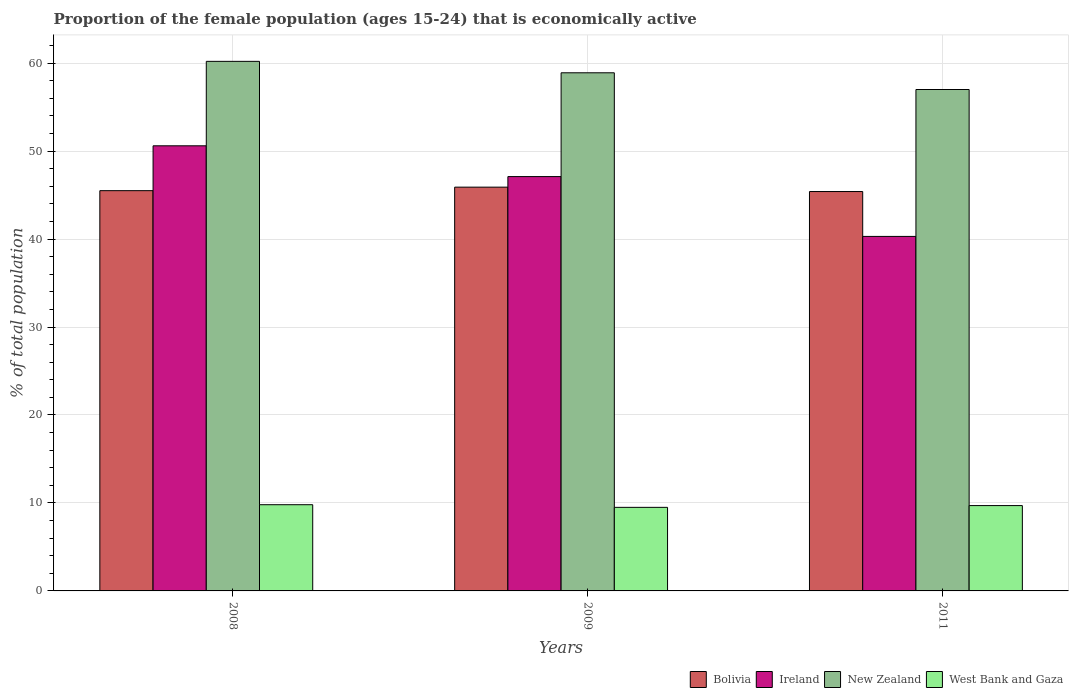Are the number of bars per tick equal to the number of legend labels?
Your response must be concise. Yes. How many bars are there on the 2nd tick from the left?
Offer a very short reply. 4. How many bars are there on the 1st tick from the right?
Provide a short and direct response. 4. What is the label of the 1st group of bars from the left?
Offer a very short reply. 2008. In how many cases, is the number of bars for a given year not equal to the number of legend labels?
Your answer should be compact. 0. What is the proportion of the female population that is economically active in West Bank and Gaza in 2008?
Ensure brevity in your answer.  9.8. Across all years, what is the maximum proportion of the female population that is economically active in Bolivia?
Ensure brevity in your answer.  45.9. Across all years, what is the minimum proportion of the female population that is economically active in West Bank and Gaza?
Provide a short and direct response. 9.5. In which year was the proportion of the female population that is economically active in New Zealand minimum?
Ensure brevity in your answer.  2011. What is the total proportion of the female population that is economically active in West Bank and Gaza in the graph?
Your answer should be compact. 29. What is the difference between the proportion of the female population that is economically active in Bolivia in 2008 and that in 2011?
Give a very brief answer. 0.1. What is the difference between the proportion of the female population that is economically active in New Zealand in 2008 and the proportion of the female population that is economically active in West Bank and Gaza in 2009?
Provide a succinct answer. 50.7. What is the average proportion of the female population that is economically active in West Bank and Gaza per year?
Provide a short and direct response. 9.67. In the year 2008, what is the difference between the proportion of the female population that is economically active in New Zealand and proportion of the female population that is economically active in West Bank and Gaza?
Provide a short and direct response. 50.4. In how many years, is the proportion of the female population that is economically active in West Bank and Gaza greater than 6 %?
Your answer should be compact. 3. What is the ratio of the proportion of the female population that is economically active in Ireland in 2008 to that in 2009?
Your answer should be compact. 1.07. Is the difference between the proportion of the female population that is economically active in New Zealand in 2008 and 2011 greater than the difference between the proportion of the female population that is economically active in West Bank and Gaza in 2008 and 2011?
Offer a very short reply. Yes. What is the difference between the highest and the second highest proportion of the female population that is economically active in West Bank and Gaza?
Your answer should be very brief. 0.1. Is it the case that in every year, the sum of the proportion of the female population that is economically active in Bolivia and proportion of the female population that is economically active in West Bank and Gaza is greater than the sum of proportion of the female population that is economically active in New Zealand and proportion of the female population that is economically active in Ireland?
Offer a terse response. Yes. What does the 3rd bar from the left in 2011 represents?
Your response must be concise. New Zealand. What does the 1st bar from the right in 2009 represents?
Provide a short and direct response. West Bank and Gaza. Are the values on the major ticks of Y-axis written in scientific E-notation?
Offer a terse response. No. How are the legend labels stacked?
Keep it short and to the point. Horizontal. What is the title of the graph?
Your response must be concise. Proportion of the female population (ages 15-24) that is economically active. Does "Albania" appear as one of the legend labels in the graph?
Keep it short and to the point. No. What is the label or title of the Y-axis?
Make the answer very short. % of total population. What is the % of total population in Bolivia in 2008?
Ensure brevity in your answer.  45.5. What is the % of total population of Ireland in 2008?
Your answer should be very brief. 50.6. What is the % of total population of New Zealand in 2008?
Give a very brief answer. 60.2. What is the % of total population of West Bank and Gaza in 2008?
Offer a very short reply. 9.8. What is the % of total population in Bolivia in 2009?
Give a very brief answer. 45.9. What is the % of total population in Ireland in 2009?
Offer a terse response. 47.1. What is the % of total population of New Zealand in 2009?
Provide a short and direct response. 58.9. What is the % of total population in West Bank and Gaza in 2009?
Provide a short and direct response. 9.5. What is the % of total population in Bolivia in 2011?
Ensure brevity in your answer.  45.4. What is the % of total population in Ireland in 2011?
Keep it short and to the point. 40.3. What is the % of total population of West Bank and Gaza in 2011?
Offer a very short reply. 9.7. Across all years, what is the maximum % of total population in Bolivia?
Provide a short and direct response. 45.9. Across all years, what is the maximum % of total population of Ireland?
Offer a terse response. 50.6. Across all years, what is the maximum % of total population in New Zealand?
Provide a succinct answer. 60.2. Across all years, what is the maximum % of total population of West Bank and Gaza?
Your response must be concise. 9.8. Across all years, what is the minimum % of total population of Bolivia?
Provide a short and direct response. 45.4. Across all years, what is the minimum % of total population of Ireland?
Make the answer very short. 40.3. Across all years, what is the minimum % of total population in West Bank and Gaza?
Keep it short and to the point. 9.5. What is the total % of total population in Bolivia in the graph?
Your response must be concise. 136.8. What is the total % of total population in Ireland in the graph?
Your response must be concise. 138. What is the total % of total population of New Zealand in the graph?
Offer a very short reply. 176.1. What is the total % of total population of West Bank and Gaza in the graph?
Offer a very short reply. 29. What is the difference between the % of total population in New Zealand in 2008 and that in 2009?
Your response must be concise. 1.3. What is the difference between the % of total population of West Bank and Gaza in 2008 and that in 2009?
Provide a succinct answer. 0.3. What is the difference between the % of total population of Bolivia in 2008 and that in 2011?
Your response must be concise. 0.1. What is the difference between the % of total population of New Zealand in 2008 and that in 2011?
Keep it short and to the point. 3.2. What is the difference between the % of total population of Ireland in 2009 and that in 2011?
Give a very brief answer. 6.8. What is the difference between the % of total population in Bolivia in 2008 and the % of total population in Ireland in 2009?
Provide a short and direct response. -1.6. What is the difference between the % of total population in Ireland in 2008 and the % of total population in New Zealand in 2009?
Offer a terse response. -8.3. What is the difference between the % of total population of Ireland in 2008 and the % of total population of West Bank and Gaza in 2009?
Your answer should be compact. 41.1. What is the difference between the % of total population in New Zealand in 2008 and the % of total population in West Bank and Gaza in 2009?
Offer a terse response. 50.7. What is the difference between the % of total population of Bolivia in 2008 and the % of total population of West Bank and Gaza in 2011?
Make the answer very short. 35.8. What is the difference between the % of total population in Ireland in 2008 and the % of total population in West Bank and Gaza in 2011?
Your answer should be very brief. 40.9. What is the difference between the % of total population in New Zealand in 2008 and the % of total population in West Bank and Gaza in 2011?
Keep it short and to the point. 50.5. What is the difference between the % of total population of Bolivia in 2009 and the % of total population of Ireland in 2011?
Ensure brevity in your answer.  5.6. What is the difference between the % of total population in Bolivia in 2009 and the % of total population in New Zealand in 2011?
Keep it short and to the point. -11.1. What is the difference between the % of total population in Bolivia in 2009 and the % of total population in West Bank and Gaza in 2011?
Ensure brevity in your answer.  36.2. What is the difference between the % of total population in Ireland in 2009 and the % of total population in West Bank and Gaza in 2011?
Ensure brevity in your answer.  37.4. What is the difference between the % of total population in New Zealand in 2009 and the % of total population in West Bank and Gaza in 2011?
Your response must be concise. 49.2. What is the average % of total population in Bolivia per year?
Offer a terse response. 45.6. What is the average % of total population of Ireland per year?
Provide a short and direct response. 46. What is the average % of total population in New Zealand per year?
Make the answer very short. 58.7. What is the average % of total population in West Bank and Gaza per year?
Your answer should be very brief. 9.67. In the year 2008, what is the difference between the % of total population in Bolivia and % of total population in Ireland?
Offer a terse response. -5.1. In the year 2008, what is the difference between the % of total population in Bolivia and % of total population in New Zealand?
Make the answer very short. -14.7. In the year 2008, what is the difference between the % of total population in Bolivia and % of total population in West Bank and Gaza?
Give a very brief answer. 35.7. In the year 2008, what is the difference between the % of total population of Ireland and % of total population of New Zealand?
Provide a short and direct response. -9.6. In the year 2008, what is the difference between the % of total population of Ireland and % of total population of West Bank and Gaza?
Provide a succinct answer. 40.8. In the year 2008, what is the difference between the % of total population in New Zealand and % of total population in West Bank and Gaza?
Offer a terse response. 50.4. In the year 2009, what is the difference between the % of total population of Bolivia and % of total population of New Zealand?
Make the answer very short. -13. In the year 2009, what is the difference between the % of total population in Bolivia and % of total population in West Bank and Gaza?
Your response must be concise. 36.4. In the year 2009, what is the difference between the % of total population of Ireland and % of total population of New Zealand?
Provide a short and direct response. -11.8. In the year 2009, what is the difference between the % of total population of Ireland and % of total population of West Bank and Gaza?
Your response must be concise. 37.6. In the year 2009, what is the difference between the % of total population in New Zealand and % of total population in West Bank and Gaza?
Provide a short and direct response. 49.4. In the year 2011, what is the difference between the % of total population in Bolivia and % of total population in West Bank and Gaza?
Make the answer very short. 35.7. In the year 2011, what is the difference between the % of total population of Ireland and % of total population of New Zealand?
Provide a short and direct response. -16.7. In the year 2011, what is the difference between the % of total population in Ireland and % of total population in West Bank and Gaza?
Your answer should be compact. 30.6. In the year 2011, what is the difference between the % of total population of New Zealand and % of total population of West Bank and Gaza?
Make the answer very short. 47.3. What is the ratio of the % of total population of Bolivia in 2008 to that in 2009?
Provide a short and direct response. 0.99. What is the ratio of the % of total population in Ireland in 2008 to that in 2009?
Make the answer very short. 1.07. What is the ratio of the % of total population of New Zealand in 2008 to that in 2009?
Provide a succinct answer. 1.02. What is the ratio of the % of total population of West Bank and Gaza in 2008 to that in 2009?
Provide a short and direct response. 1.03. What is the ratio of the % of total population in Ireland in 2008 to that in 2011?
Your answer should be compact. 1.26. What is the ratio of the % of total population in New Zealand in 2008 to that in 2011?
Offer a very short reply. 1.06. What is the ratio of the % of total population of West Bank and Gaza in 2008 to that in 2011?
Make the answer very short. 1.01. What is the ratio of the % of total population of Ireland in 2009 to that in 2011?
Ensure brevity in your answer.  1.17. What is the ratio of the % of total population in New Zealand in 2009 to that in 2011?
Your answer should be compact. 1.03. What is the ratio of the % of total population of West Bank and Gaza in 2009 to that in 2011?
Provide a succinct answer. 0.98. What is the difference between the highest and the second highest % of total population in Bolivia?
Keep it short and to the point. 0.4. What is the difference between the highest and the second highest % of total population of New Zealand?
Offer a very short reply. 1.3. What is the difference between the highest and the lowest % of total population in Bolivia?
Give a very brief answer. 0.5. What is the difference between the highest and the lowest % of total population in Ireland?
Provide a succinct answer. 10.3. What is the difference between the highest and the lowest % of total population of West Bank and Gaza?
Ensure brevity in your answer.  0.3. 